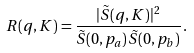Convert formula to latex. <formula><loc_0><loc_0><loc_500><loc_500>R ( { q } , { K } ) = \frac { | \tilde { S } ( { q } , { K } ) | ^ { 2 } } { \tilde { S } ( { 0 } , { p } _ { a } ) \, \tilde { S } ( { 0 } , { p } _ { b } ) } \, .</formula> 